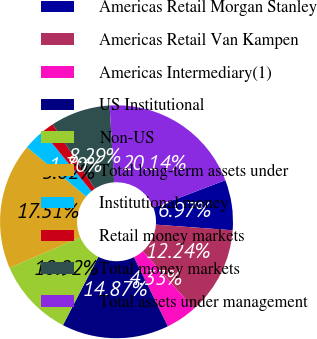Convert chart to OTSL. <chart><loc_0><loc_0><loc_500><loc_500><pie_chart><fcel>Americas Retail Morgan Stanley<fcel>Americas Retail Van Kampen<fcel>Americas Intermediary(1)<fcel>US Institutional<fcel>Non-US<fcel>Total long-term assets under<fcel>Institutional money<fcel>Retail money markets<fcel>Total money markets<fcel>Total assets under management<nl><fcel>6.97%<fcel>12.24%<fcel>4.33%<fcel>14.87%<fcel>10.92%<fcel>17.51%<fcel>3.02%<fcel>1.7%<fcel>8.29%<fcel>20.14%<nl></chart> 